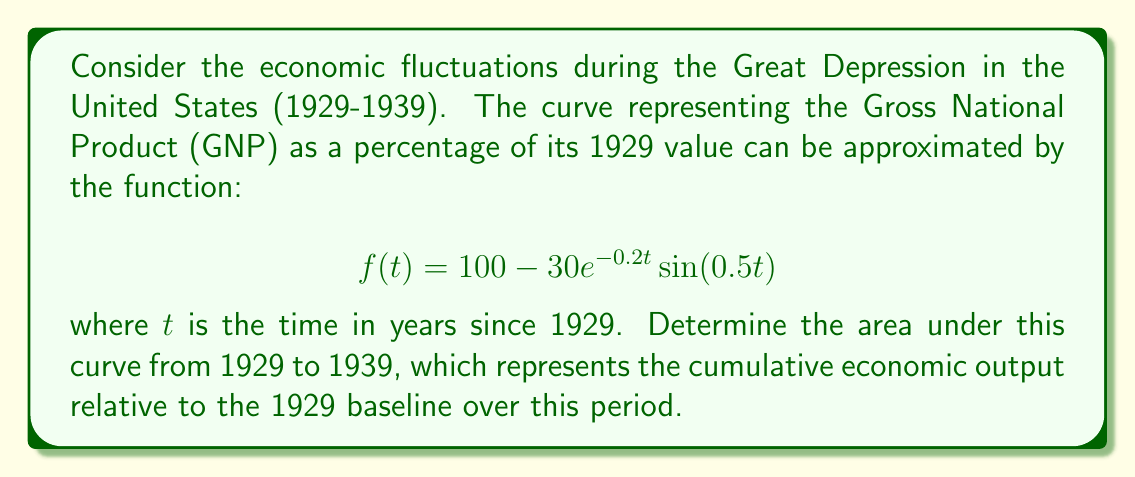Help me with this question. To find the area under the curve, we need to integrate the function from $t=0$ to $t=10$ (representing the years 1929 to 1939):

$$ \int_0^{10} f(t) dt = \int_0^{10} (100 - 30e^{-0.2t}\sin(0.5t)) dt $$

Let's break this into two parts:

1. $\int_0^{10} 100 dt = 100t \Big|_0^{10} = 1000$

2. $-30 \int_0^{10} e^{-0.2t}\sin(0.5t) dt$

For the second part, we can use integration by parts. Let:
$u = \sin(0.5t)$, $du = 0.5\cos(0.5t)dt$
$dv = e^{-0.2t}dt$, $v = -5e^{-0.2t}$

$$ -30 \int_0^{10} e^{-0.2t}\sin(0.5t) dt = -30 \left[ -5e^{-0.2t}\sin(0.5t) \Big|_0^{10} + 2.5 \int_0^{10} e^{-0.2t}\cos(0.5t) dt \right] $$

The first term evaluates to:
$$ 150e^{-2}\sin(5) - 0 = 150e^{-2}\sin(5) $$

For the remaining integral, we can use integration by parts again:
$u = \cos(0.5t)$, $du = -0.5\sin(0.5t)dt$
$dv = e^{-0.2t}dt$, $v = -5e^{-0.2t}$

$$ 75 \left[ -5e^{-0.2t}\cos(0.5t) \Big|_0^{10} - 2.5 \int_0^{10} e^{-0.2t}\sin(0.5t) dt \right] $$

The first term evaluates to:
$$ -375e^{-2}\cos(5) + 375 $$

The remaining integral is the negative of what we started with, so we can solve for it:

$$ x = 150e^{-2}\sin(5) - 375e^{-2}\cos(5) + 375 - 2.5x $$
$$ 3.5x = 150e^{-2}\sin(5) - 375e^{-2}\cos(5) + 375 $$
$$ x = \frac{150e^{-2}\sin(5) - 375e^{-2}\cos(5) + 375}{3.5} $$

Adding this to 1000 from the first part gives our final result.
Answer: $1000 + \frac{150e^{-2}\sin(5) - 375e^{-2}\cos(5) + 375}{3.5} \approx 1092.86$ 